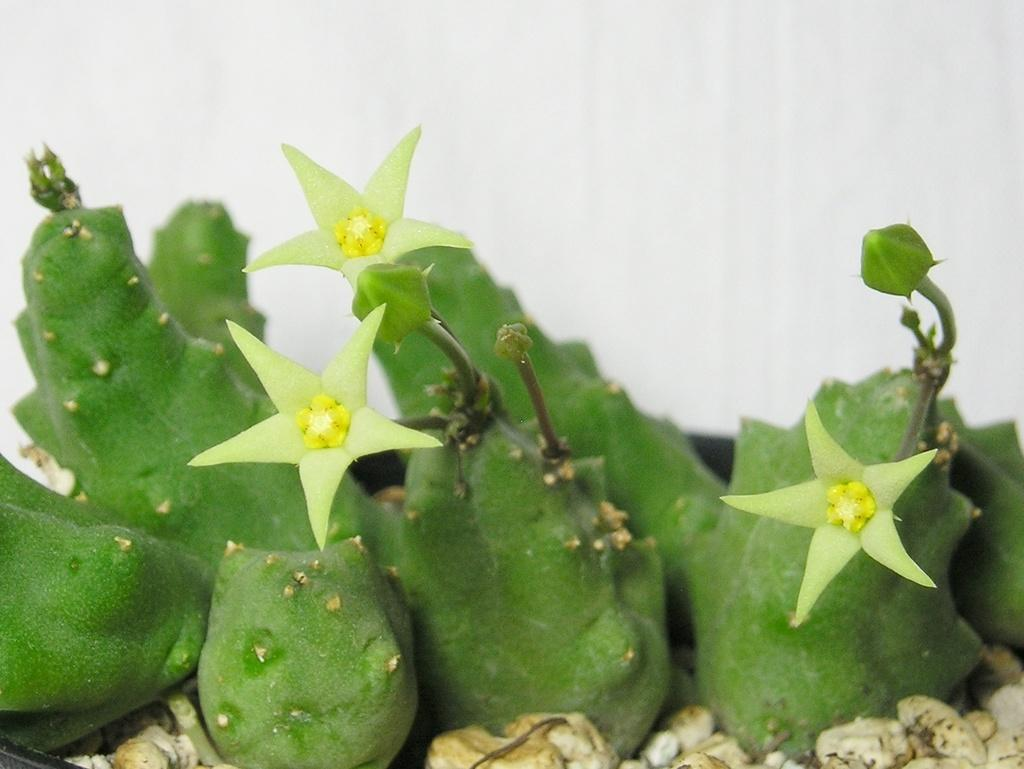What type of living organisms can be seen in the image? Plants can be seen in the image. What color is the background of the image? The background of the image is white. What type of fang can be seen in the image? There is no fang present in the image; it features plants and a white background. What type of lace is draped over the plants in the image? There is no lace present in the image; it only shows plants and a white background. 